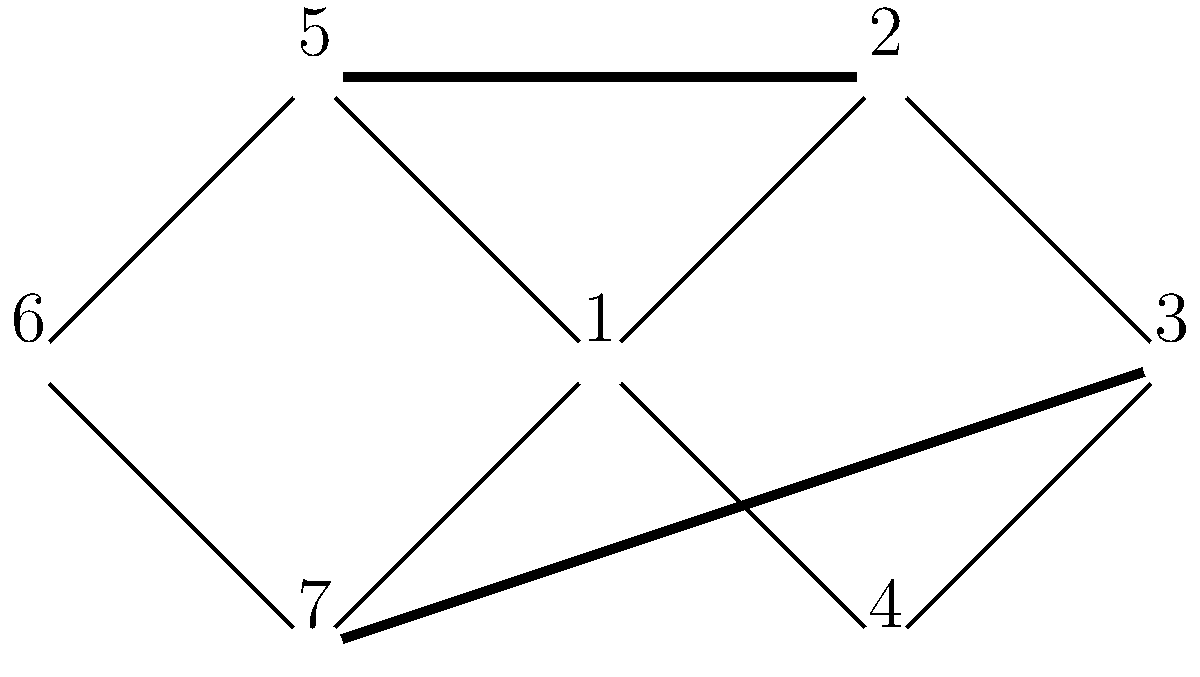In the given social network graph representing team connections, identify the strongest bridges that, if removed, would significantly impact the team's communication and collaboration. How many such bridges exist, and what makes them crucial for maintaining team unity? To identify the strongest bridges in this social network graph, we need to follow these steps:

1. Understand the concept of bridges: Bridges are edges that, when removed, increase the number of connected components in the graph.

2. Analyze the graph structure:
   - The graph consists of 7 nodes (team members) and 8 edges (connections).
   - There are two main clusters: {1, 2, 3, 4} and {1, 5, 6, 7}.

3. Identify potential bridges:
   - Edge 1-5 connects the two main clusters.
   - Edge 2-7 also connects the two main clusters.

4. Evaluate the impact of removing these edges:
   - Removing edge 1-5 would disconnect node 5 from the rest of the network.
   - Removing edge 2-7 would disconnect node 7 from the rest of the network.

5. Assess the importance of these bridges:
   - Both edges 1-5 and 2-7 are crucial for maintaining team unity as they connect different parts of the network.
   - Removing either of these edges would significantly impact communication and collaboration between the two main clusters.

6. Count the number of strongest bridges:
   - There are 2 strongest bridges in this network (edges 1-5 and 2-7).

These bridges are crucial because they ensure that all team members can communicate and collaborate effectively, maintaining team unity across different subgroups within the organization.
Answer: 2 strongest bridges (edges 1-5 and 2-7) 